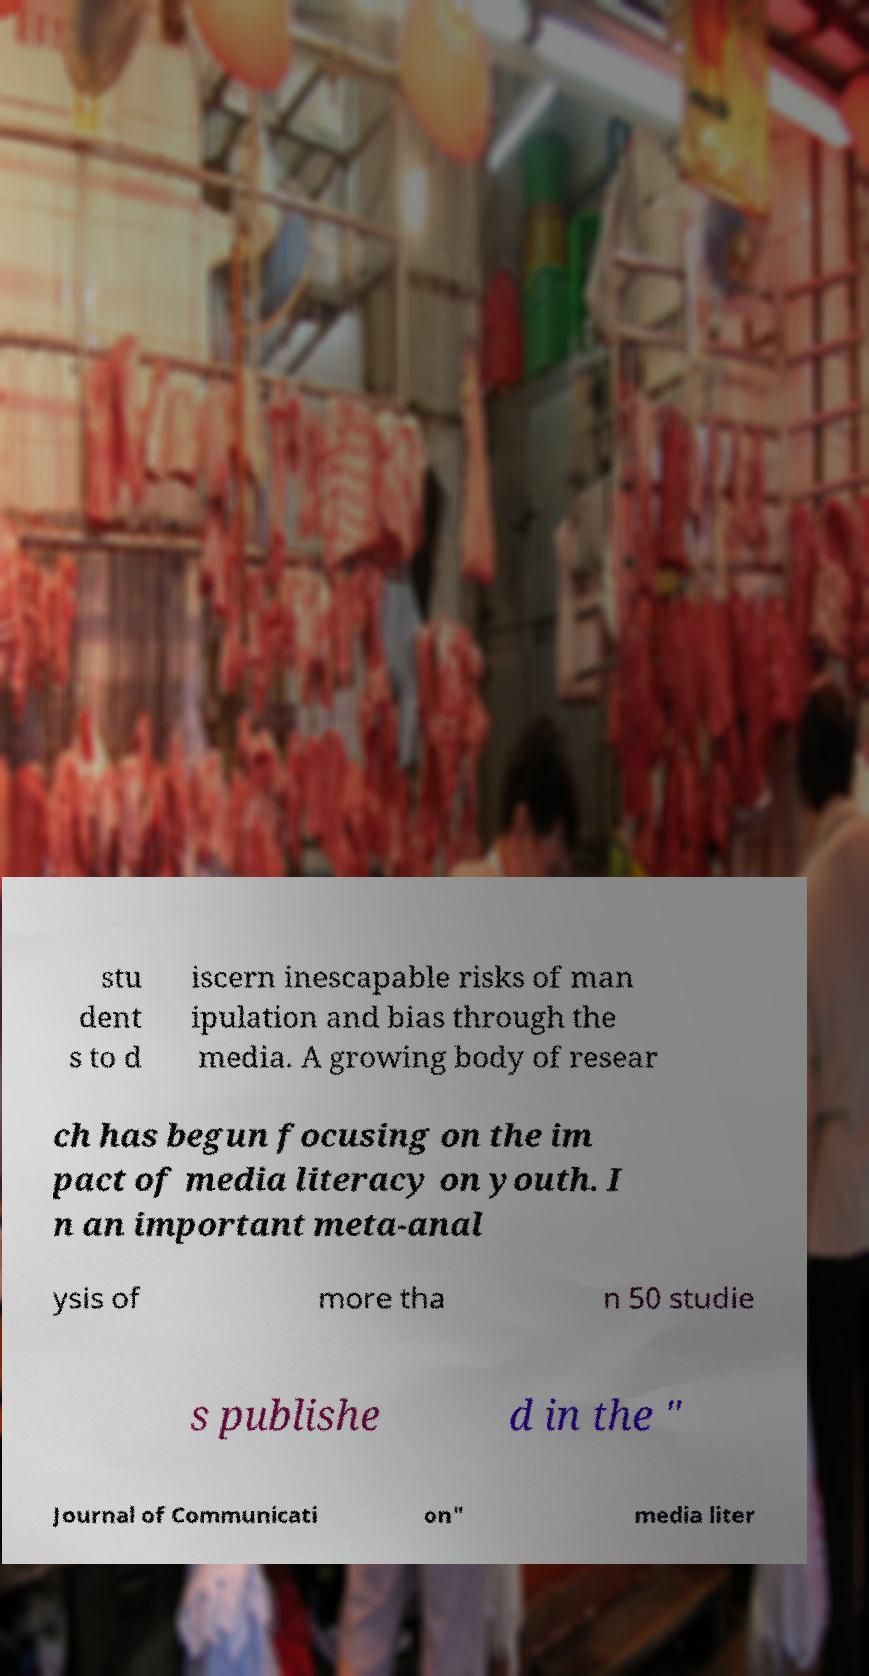Could you assist in decoding the text presented in this image and type it out clearly? stu dent s to d iscern inescapable risks of man ipulation and bias through the media. A growing body of resear ch has begun focusing on the im pact of media literacy on youth. I n an important meta-anal ysis of more tha n 50 studie s publishe d in the " Journal of Communicati on" media liter 